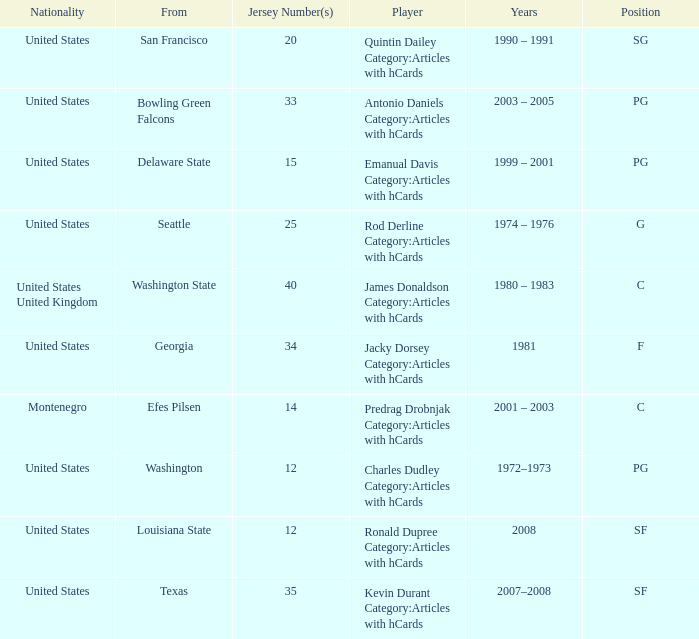What college was the player with the jersey number of 34 from? Georgia. 